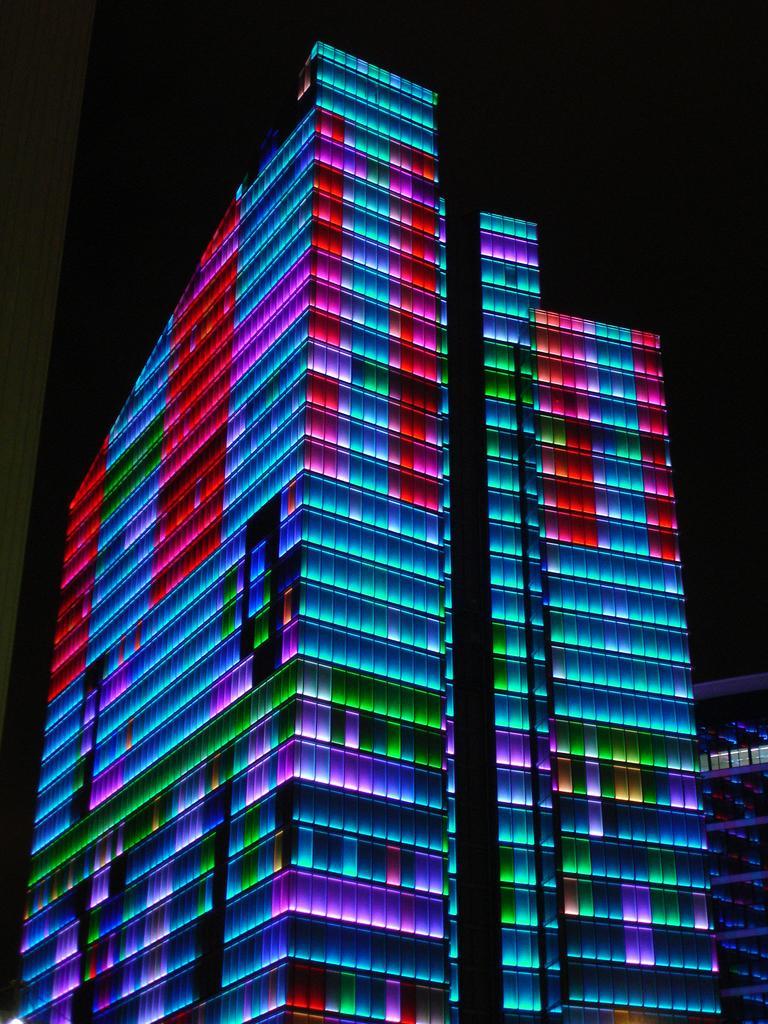Please provide a concise description of this image. In the image there is a building with colorful lights. And there is a dark background. 